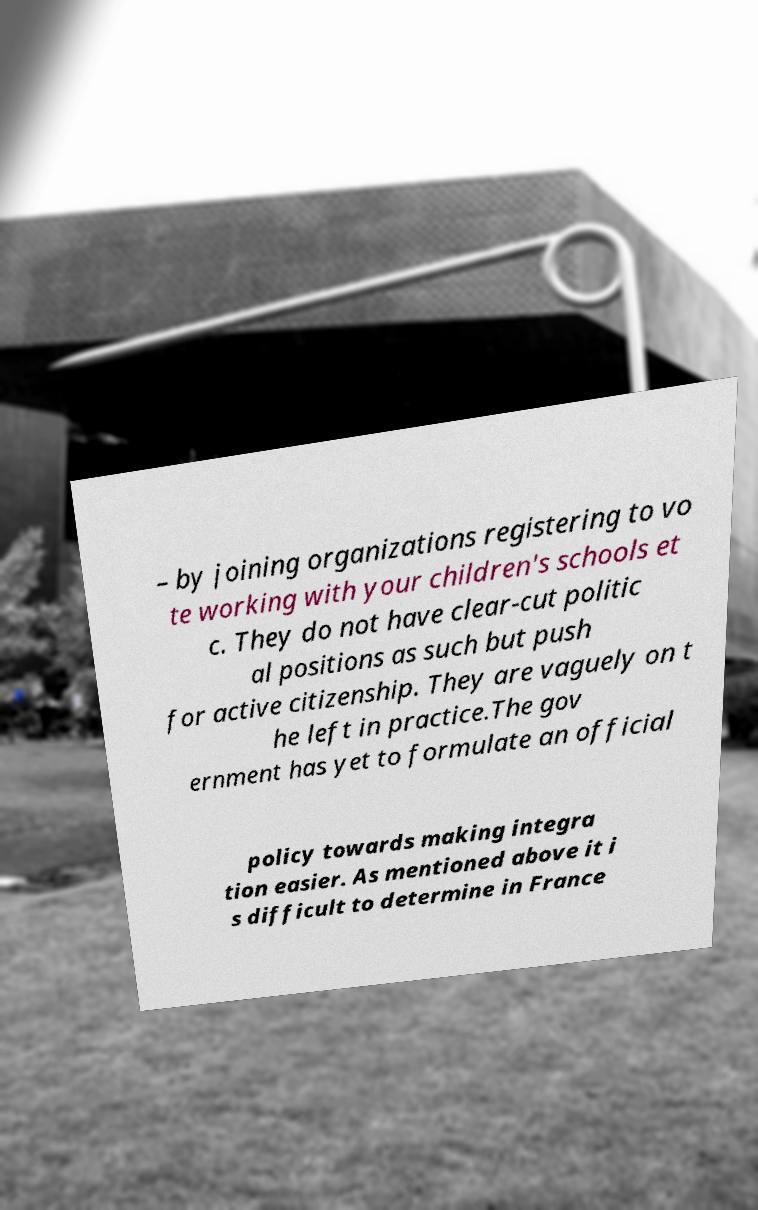Can you read and provide the text displayed in the image?This photo seems to have some interesting text. Can you extract and type it out for me? – by joining organizations registering to vo te working with your children's schools et c. They do not have clear-cut politic al positions as such but push for active citizenship. They are vaguely on t he left in practice.The gov ernment has yet to formulate an official policy towards making integra tion easier. As mentioned above it i s difficult to determine in France 